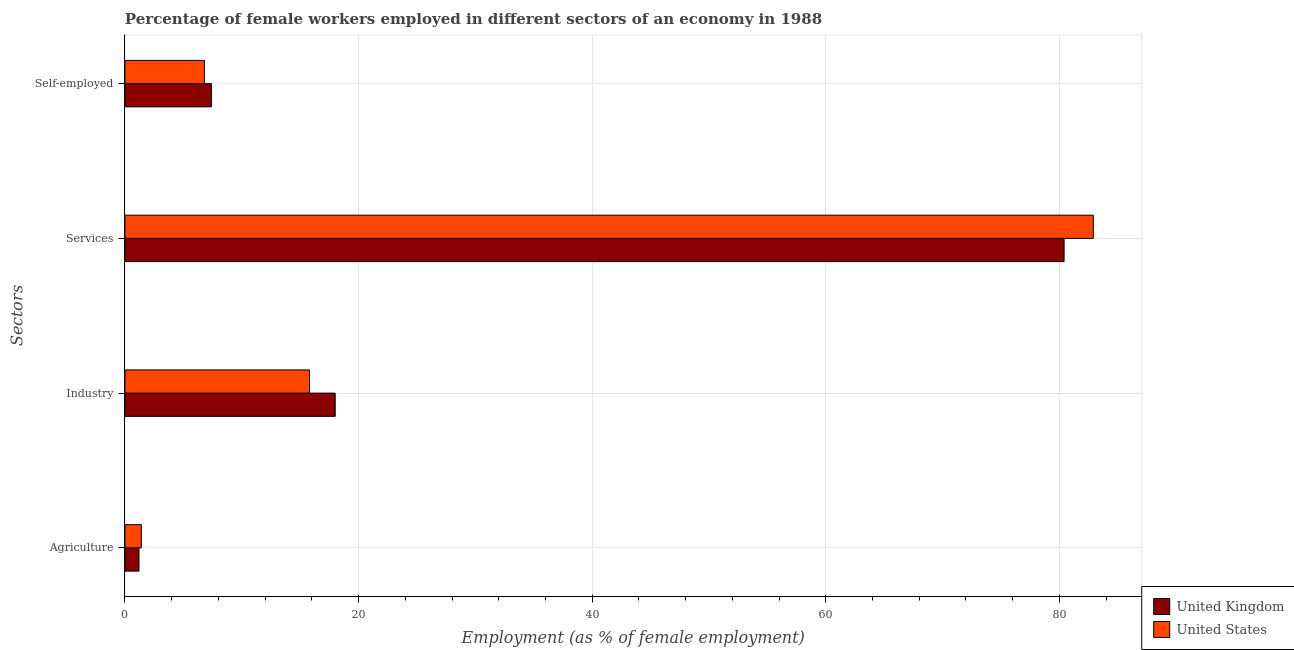How many different coloured bars are there?
Your response must be concise. 2. How many bars are there on the 1st tick from the bottom?
Your answer should be very brief. 2. What is the label of the 4th group of bars from the top?
Make the answer very short. Agriculture. What is the percentage of female workers in agriculture in United Kingdom?
Offer a very short reply. 1.2. Across all countries, what is the minimum percentage of female workers in agriculture?
Offer a terse response. 1.2. In which country was the percentage of female workers in services minimum?
Your answer should be compact. United Kingdom. What is the total percentage of female workers in agriculture in the graph?
Keep it short and to the point. 2.6. What is the difference between the percentage of female workers in agriculture in United Kingdom and that in United States?
Your response must be concise. -0.2. What is the difference between the percentage of female workers in industry in United States and the percentage of female workers in agriculture in United Kingdom?
Provide a succinct answer. 14.6. What is the average percentage of self employed female workers per country?
Give a very brief answer. 7.1. What is the difference between the percentage of self employed female workers and percentage of female workers in industry in United Kingdom?
Offer a very short reply. -10.6. What is the ratio of the percentage of female workers in services in United States to that in United Kingdom?
Your answer should be compact. 1.03. What is the difference between the highest and the second highest percentage of female workers in services?
Provide a succinct answer. 2.5. In how many countries, is the percentage of self employed female workers greater than the average percentage of self employed female workers taken over all countries?
Your response must be concise. 1. What does the 1st bar from the top in Self-employed represents?
Provide a succinct answer. United States. Is it the case that in every country, the sum of the percentage of female workers in agriculture and percentage of female workers in industry is greater than the percentage of female workers in services?
Make the answer very short. No. What is the difference between two consecutive major ticks on the X-axis?
Your response must be concise. 20. Are the values on the major ticks of X-axis written in scientific E-notation?
Offer a terse response. No. Does the graph contain any zero values?
Give a very brief answer. No. Does the graph contain grids?
Your answer should be compact. Yes. How are the legend labels stacked?
Your answer should be very brief. Vertical. What is the title of the graph?
Your answer should be very brief. Percentage of female workers employed in different sectors of an economy in 1988. What is the label or title of the X-axis?
Make the answer very short. Employment (as % of female employment). What is the label or title of the Y-axis?
Your answer should be compact. Sectors. What is the Employment (as % of female employment) of United Kingdom in Agriculture?
Offer a terse response. 1.2. What is the Employment (as % of female employment) of United States in Agriculture?
Provide a short and direct response. 1.4. What is the Employment (as % of female employment) of United Kingdom in Industry?
Your answer should be very brief. 18. What is the Employment (as % of female employment) in United States in Industry?
Provide a succinct answer. 15.8. What is the Employment (as % of female employment) of United Kingdom in Services?
Offer a very short reply. 80.4. What is the Employment (as % of female employment) in United States in Services?
Your response must be concise. 82.9. What is the Employment (as % of female employment) in United Kingdom in Self-employed?
Offer a very short reply. 7.4. What is the Employment (as % of female employment) of United States in Self-employed?
Provide a succinct answer. 6.8. Across all Sectors, what is the maximum Employment (as % of female employment) in United Kingdom?
Provide a succinct answer. 80.4. Across all Sectors, what is the maximum Employment (as % of female employment) in United States?
Offer a terse response. 82.9. Across all Sectors, what is the minimum Employment (as % of female employment) in United Kingdom?
Give a very brief answer. 1.2. Across all Sectors, what is the minimum Employment (as % of female employment) of United States?
Give a very brief answer. 1.4. What is the total Employment (as % of female employment) in United Kingdom in the graph?
Provide a short and direct response. 107. What is the total Employment (as % of female employment) of United States in the graph?
Your answer should be compact. 106.9. What is the difference between the Employment (as % of female employment) of United Kingdom in Agriculture and that in Industry?
Offer a very short reply. -16.8. What is the difference between the Employment (as % of female employment) of United States in Agriculture and that in Industry?
Give a very brief answer. -14.4. What is the difference between the Employment (as % of female employment) in United Kingdom in Agriculture and that in Services?
Make the answer very short. -79.2. What is the difference between the Employment (as % of female employment) of United States in Agriculture and that in Services?
Provide a short and direct response. -81.5. What is the difference between the Employment (as % of female employment) in United States in Agriculture and that in Self-employed?
Offer a terse response. -5.4. What is the difference between the Employment (as % of female employment) of United Kingdom in Industry and that in Services?
Provide a short and direct response. -62.4. What is the difference between the Employment (as % of female employment) in United States in Industry and that in Services?
Ensure brevity in your answer.  -67.1. What is the difference between the Employment (as % of female employment) in United States in Services and that in Self-employed?
Your response must be concise. 76.1. What is the difference between the Employment (as % of female employment) in United Kingdom in Agriculture and the Employment (as % of female employment) in United States in Industry?
Give a very brief answer. -14.6. What is the difference between the Employment (as % of female employment) of United Kingdom in Agriculture and the Employment (as % of female employment) of United States in Services?
Provide a short and direct response. -81.7. What is the difference between the Employment (as % of female employment) of United Kingdom in Industry and the Employment (as % of female employment) of United States in Services?
Offer a very short reply. -64.9. What is the difference between the Employment (as % of female employment) of United Kingdom in Services and the Employment (as % of female employment) of United States in Self-employed?
Your answer should be very brief. 73.6. What is the average Employment (as % of female employment) in United Kingdom per Sectors?
Ensure brevity in your answer.  26.75. What is the average Employment (as % of female employment) in United States per Sectors?
Give a very brief answer. 26.73. What is the difference between the Employment (as % of female employment) of United Kingdom and Employment (as % of female employment) of United States in Agriculture?
Offer a terse response. -0.2. What is the difference between the Employment (as % of female employment) of United Kingdom and Employment (as % of female employment) of United States in Self-employed?
Keep it short and to the point. 0.6. What is the ratio of the Employment (as % of female employment) in United Kingdom in Agriculture to that in Industry?
Offer a terse response. 0.07. What is the ratio of the Employment (as % of female employment) in United States in Agriculture to that in Industry?
Your answer should be very brief. 0.09. What is the ratio of the Employment (as % of female employment) of United Kingdom in Agriculture to that in Services?
Give a very brief answer. 0.01. What is the ratio of the Employment (as % of female employment) of United States in Agriculture to that in Services?
Your answer should be compact. 0.02. What is the ratio of the Employment (as % of female employment) in United Kingdom in Agriculture to that in Self-employed?
Provide a succinct answer. 0.16. What is the ratio of the Employment (as % of female employment) in United States in Agriculture to that in Self-employed?
Keep it short and to the point. 0.21. What is the ratio of the Employment (as % of female employment) in United Kingdom in Industry to that in Services?
Your answer should be very brief. 0.22. What is the ratio of the Employment (as % of female employment) of United States in Industry to that in Services?
Keep it short and to the point. 0.19. What is the ratio of the Employment (as % of female employment) in United Kingdom in Industry to that in Self-employed?
Your response must be concise. 2.43. What is the ratio of the Employment (as % of female employment) in United States in Industry to that in Self-employed?
Make the answer very short. 2.32. What is the ratio of the Employment (as % of female employment) in United Kingdom in Services to that in Self-employed?
Offer a very short reply. 10.86. What is the ratio of the Employment (as % of female employment) of United States in Services to that in Self-employed?
Your answer should be very brief. 12.19. What is the difference between the highest and the second highest Employment (as % of female employment) in United Kingdom?
Make the answer very short. 62.4. What is the difference between the highest and the second highest Employment (as % of female employment) in United States?
Your response must be concise. 67.1. What is the difference between the highest and the lowest Employment (as % of female employment) of United Kingdom?
Your answer should be very brief. 79.2. What is the difference between the highest and the lowest Employment (as % of female employment) in United States?
Your response must be concise. 81.5. 